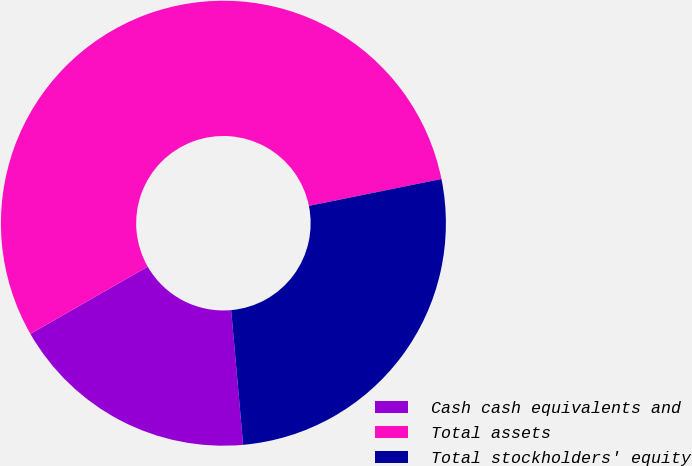Convert chart to OTSL. <chart><loc_0><loc_0><loc_500><loc_500><pie_chart><fcel>Cash cash equivalents and<fcel>Total assets<fcel>Total stockholders' equity<nl><fcel>18.13%<fcel>55.1%<fcel>26.77%<nl></chart> 